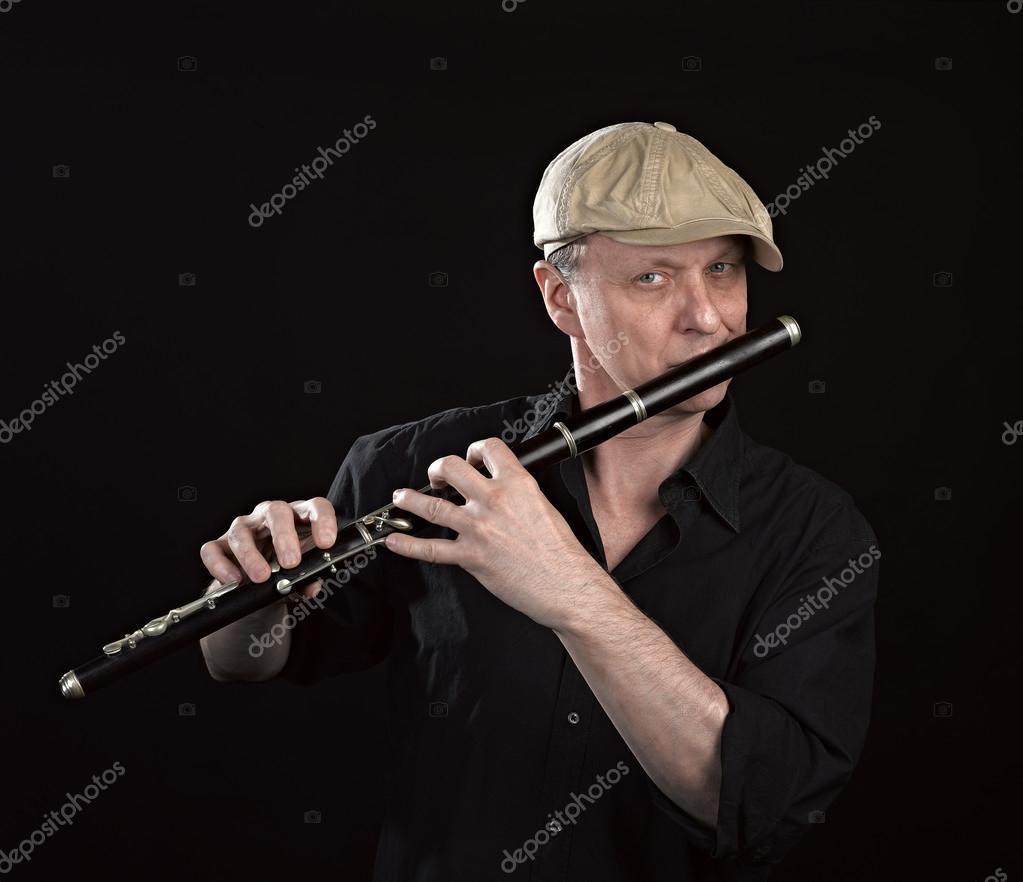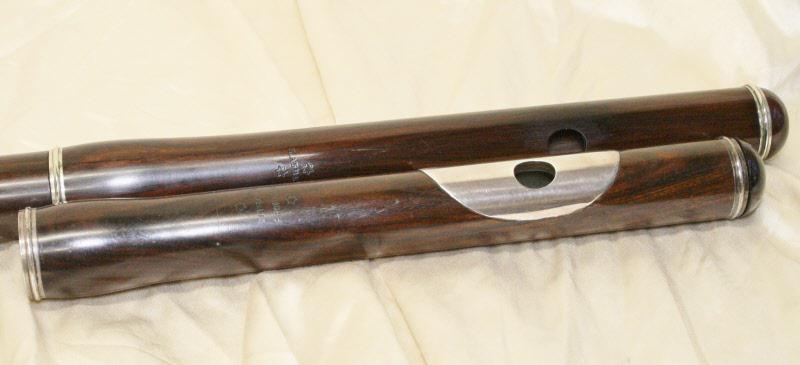The first image is the image on the left, the second image is the image on the right. Given the left and right images, does the statement "There is exactly one assembled flute in the left image." hold true? Answer yes or no. Yes. The first image is the image on the left, the second image is the image on the right. For the images displayed, is the sentence "There are two flutes and one of them is in two pieces." factually correct? Answer yes or no. Yes. 